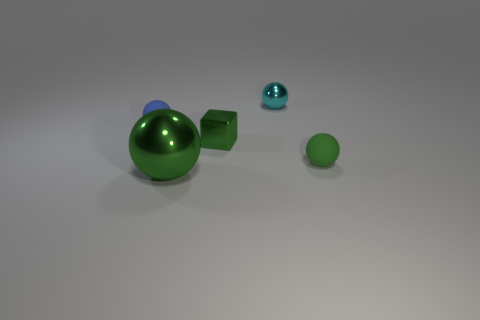Subtract 1 spheres. How many spheres are left? 3 Subtract all green balls. Subtract all brown cylinders. How many balls are left? 2 Add 2 cyan metal cubes. How many objects exist? 7 Subtract all blocks. How many objects are left? 4 Add 1 small cyan things. How many small cyan things are left? 2 Add 1 small green matte cylinders. How many small green matte cylinders exist? 1 Subtract 0 brown balls. How many objects are left? 5 Subtract all tiny green rubber things. Subtract all large yellow shiny balls. How many objects are left? 4 